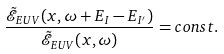<formula> <loc_0><loc_0><loc_500><loc_500>\frac { \tilde { \mathcal { E } } _ { E U V } ( x , \omega + E _ { I } - E _ { I ^ { \prime } } ) } { \tilde { \mathcal { E } } _ { E U V } ( x , \omega ) } = c o n s t .</formula> 